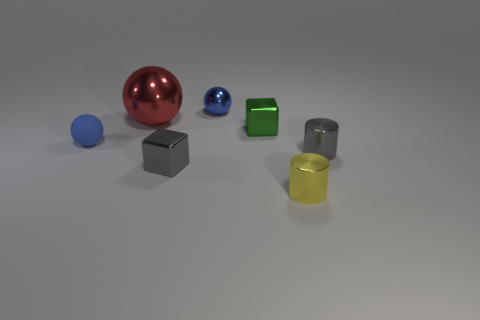Are there an equal number of small spheres that are in front of the tiny gray cylinder and small blue metallic balls in front of the green metallic object?
Ensure brevity in your answer.  Yes. There is a metallic block that is behind the small blue rubber object; what color is it?
Provide a short and direct response. Green. There is a large object; is its color the same as the block that is left of the small green shiny block?
Keep it short and to the point. No. Is the number of gray cubes less than the number of green balls?
Ensure brevity in your answer.  No. There is a cylinder in front of the gray metallic cylinder; does it have the same color as the tiny shiny ball?
Make the answer very short. No. What number of blue objects have the same size as the blue matte ball?
Provide a short and direct response. 1. Is there a big metallic ball of the same color as the tiny matte thing?
Your answer should be very brief. No. Do the tiny yellow object and the big ball have the same material?
Ensure brevity in your answer.  Yes. How many other blue metal things are the same shape as the small blue metallic object?
Make the answer very short. 0. What is the shape of the blue thing that is the same material as the green block?
Your response must be concise. Sphere. 